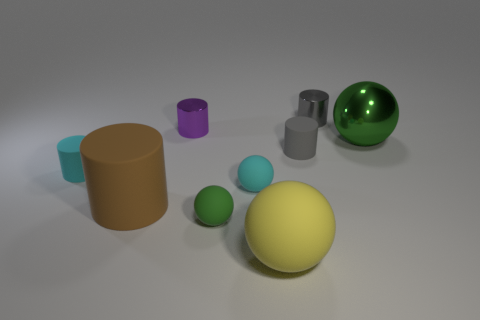Subtract all tiny cyan cylinders. How many cylinders are left? 4 Subtract all balls. How many objects are left? 5 Subtract all cyan spheres. How many spheres are left? 3 Subtract 1 balls. How many balls are left? 3 Subtract all gray balls. Subtract all brown cubes. How many balls are left? 4 Subtract all yellow cylinders. How many blue balls are left? 0 Subtract all small green spheres. Subtract all big yellow rubber spheres. How many objects are left? 7 Add 8 tiny gray metallic objects. How many tiny gray metallic objects are left? 9 Add 2 tiny gray shiny cylinders. How many tiny gray shiny cylinders exist? 3 Subtract 0 gray balls. How many objects are left? 9 